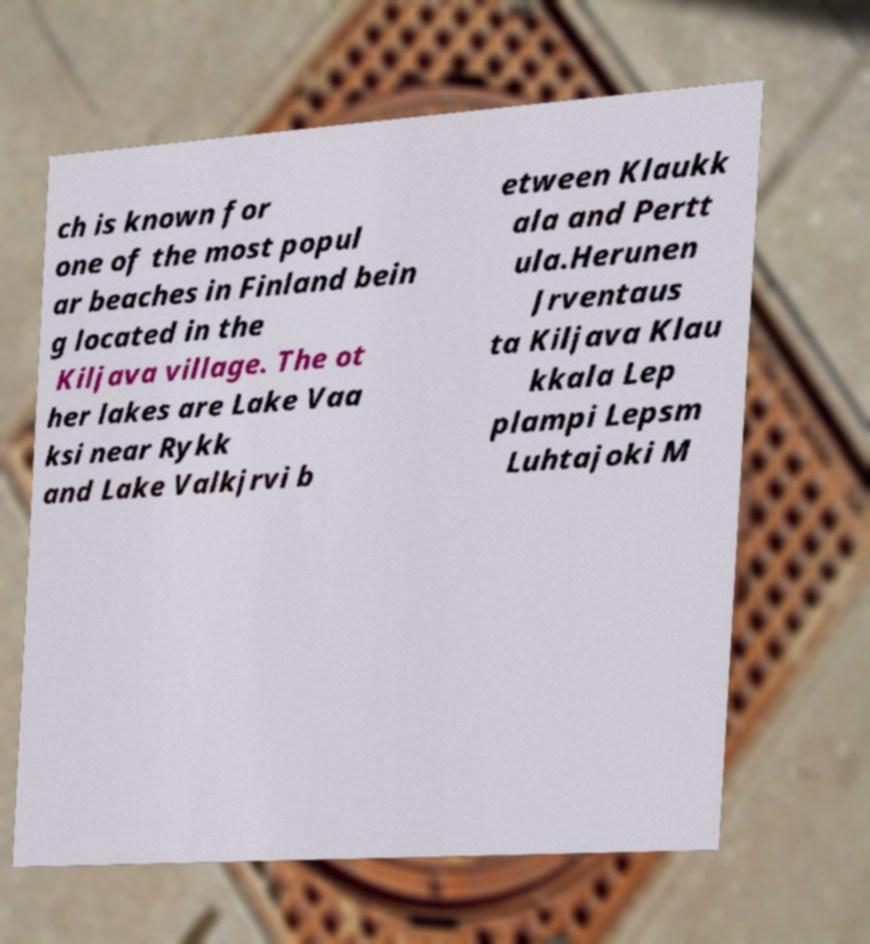What messages or text are displayed in this image? I need them in a readable, typed format. ch is known for one of the most popul ar beaches in Finland bein g located in the Kiljava village. The ot her lakes are Lake Vaa ksi near Rykk and Lake Valkjrvi b etween Klaukk ala and Pertt ula.Herunen Jrventaus ta Kiljava Klau kkala Lep plampi Lepsm Luhtajoki M 